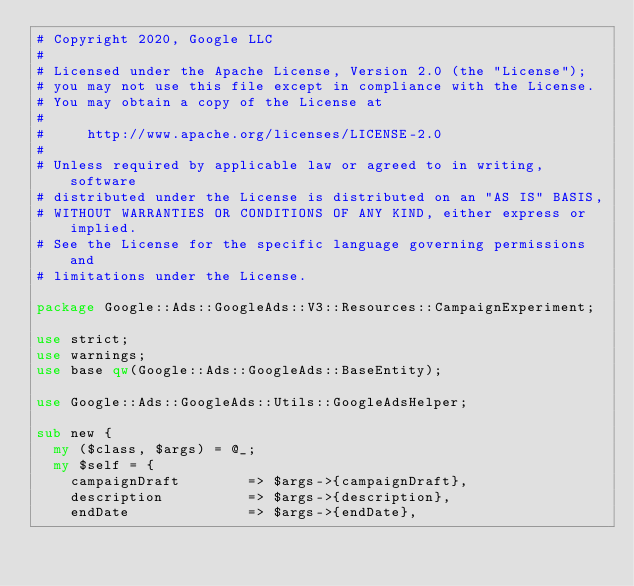<code> <loc_0><loc_0><loc_500><loc_500><_Perl_># Copyright 2020, Google LLC
#
# Licensed under the Apache License, Version 2.0 (the "License");
# you may not use this file except in compliance with the License.
# You may obtain a copy of the License at
#
#     http://www.apache.org/licenses/LICENSE-2.0
#
# Unless required by applicable law or agreed to in writing, software
# distributed under the License is distributed on an "AS IS" BASIS,
# WITHOUT WARRANTIES OR CONDITIONS OF ANY KIND, either express or implied.
# See the License for the specific language governing permissions and
# limitations under the License.

package Google::Ads::GoogleAds::V3::Resources::CampaignExperiment;

use strict;
use warnings;
use base qw(Google::Ads::GoogleAds::BaseEntity);

use Google::Ads::GoogleAds::Utils::GoogleAdsHelper;

sub new {
  my ($class, $args) = @_;
  my $self = {
    campaignDraft        => $args->{campaignDraft},
    description          => $args->{description},
    endDate              => $args->{endDate},</code> 